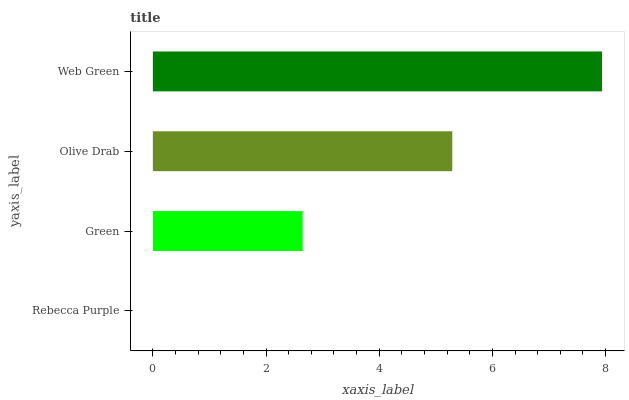Is Rebecca Purple the minimum?
Answer yes or no. Yes. Is Web Green the maximum?
Answer yes or no. Yes. Is Green the minimum?
Answer yes or no. No. Is Green the maximum?
Answer yes or no. No. Is Green greater than Rebecca Purple?
Answer yes or no. Yes. Is Rebecca Purple less than Green?
Answer yes or no. Yes. Is Rebecca Purple greater than Green?
Answer yes or no. No. Is Green less than Rebecca Purple?
Answer yes or no. No. Is Olive Drab the high median?
Answer yes or no. Yes. Is Green the low median?
Answer yes or no. Yes. Is Green the high median?
Answer yes or no. No. Is Web Green the low median?
Answer yes or no. No. 